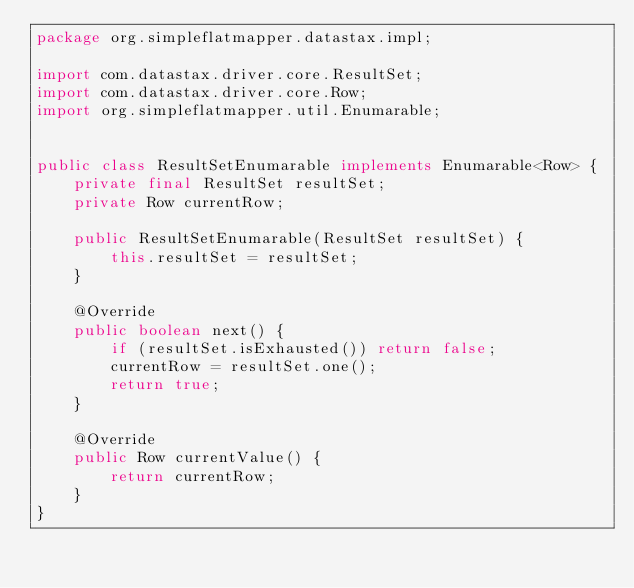<code> <loc_0><loc_0><loc_500><loc_500><_Java_>package org.simpleflatmapper.datastax.impl;

import com.datastax.driver.core.ResultSet;
import com.datastax.driver.core.Row;
import org.simpleflatmapper.util.Enumarable;


public class ResultSetEnumarable implements Enumarable<Row> {
    private final ResultSet resultSet;
    private Row currentRow;

    public ResultSetEnumarable(ResultSet resultSet) {
        this.resultSet = resultSet;
    }

    @Override
    public boolean next() {
        if (resultSet.isExhausted()) return false;
        currentRow = resultSet.one();
        return true;
    }

    @Override
    public Row currentValue() {
        return currentRow;
    }
}
</code> 